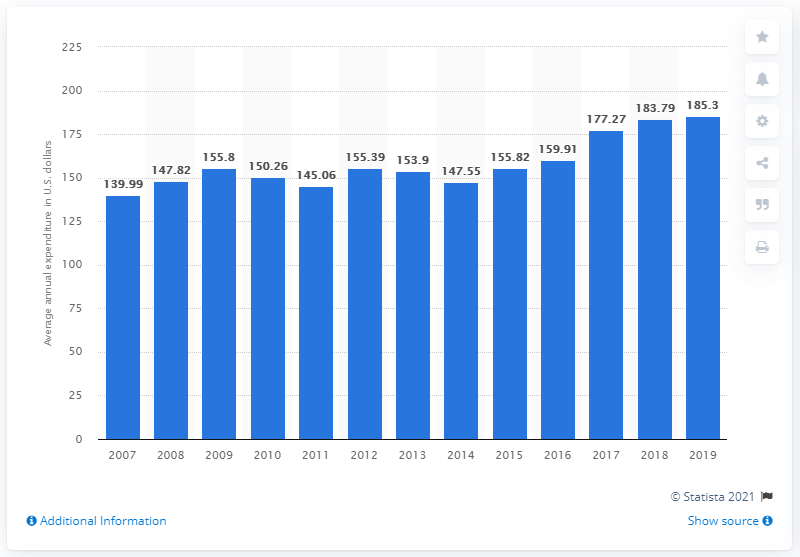Identify some key points in this picture. In 2014, the average expenditure on laundry and cleaning supplies in the United States was approximately $147.55 per person. 